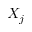<formula> <loc_0><loc_0><loc_500><loc_500>X _ { j }</formula> 